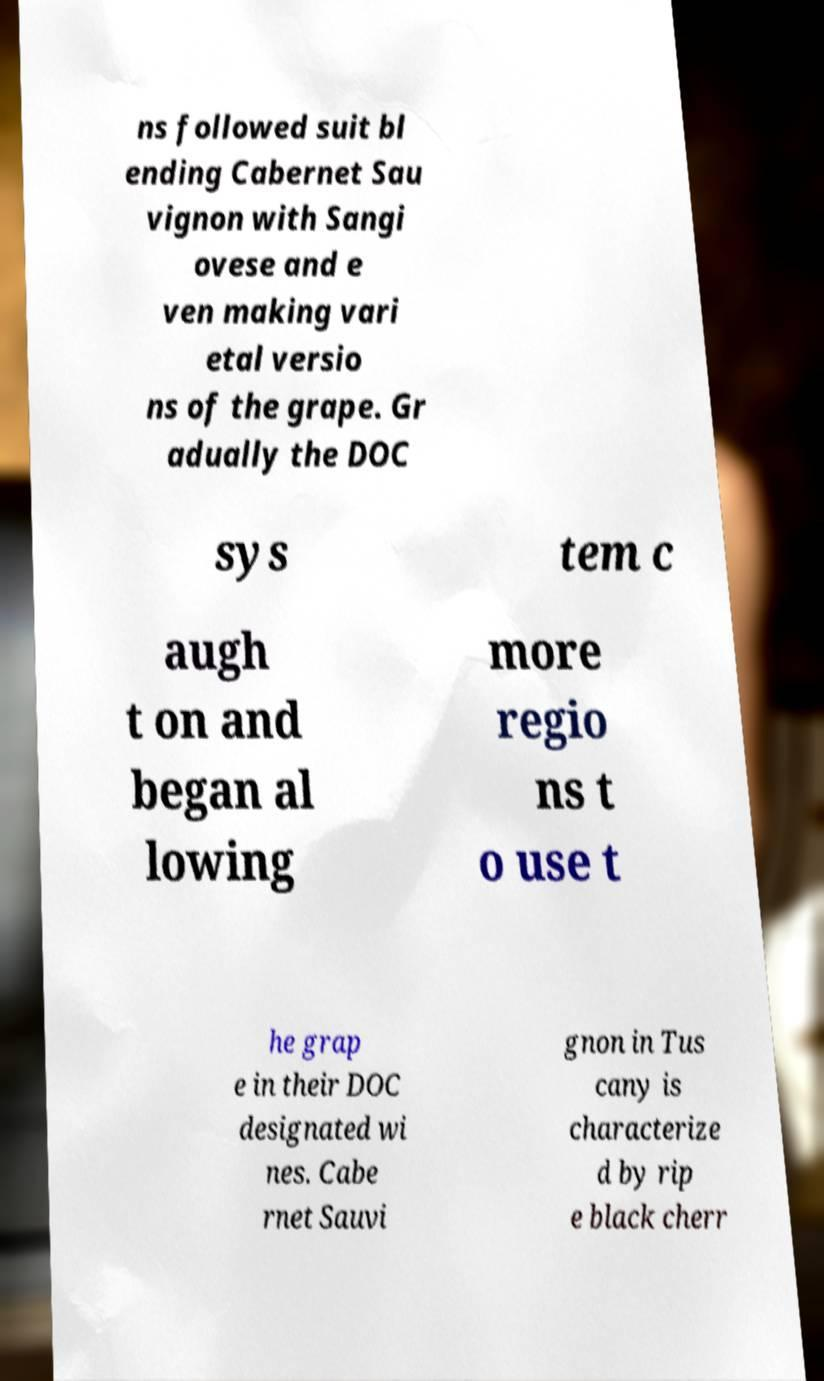Could you assist in decoding the text presented in this image and type it out clearly? ns followed suit bl ending Cabernet Sau vignon with Sangi ovese and e ven making vari etal versio ns of the grape. Gr adually the DOC sys tem c augh t on and began al lowing more regio ns t o use t he grap e in their DOC designated wi nes. Cabe rnet Sauvi gnon in Tus cany is characterize d by rip e black cherr 